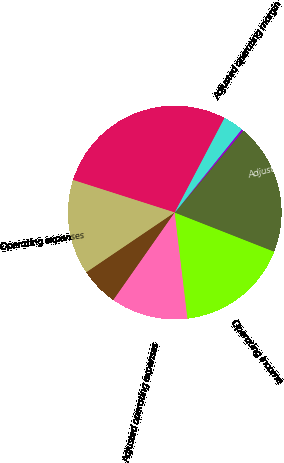Convert chart. <chart><loc_0><loc_0><loc_500><loc_500><pie_chart><fcel>Total revenues less<fcel>Operating expenses<fcel>Less Amortization of<fcel>Adjusted operating expenses<fcel>Operating income<fcel>Adjusted operating income<fcel>Operating margin<fcel>Adjusted operating margin<nl><fcel>27.79%<fcel>14.39%<fcel>5.8%<fcel>11.64%<fcel>17.13%<fcel>19.88%<fcel>0.31%<fcel>3.06%<nl></chart> 